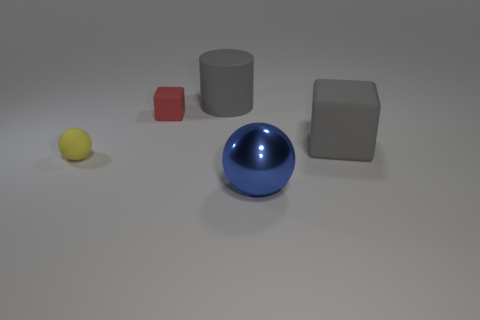Add 3 cyan rubber cylinders. How many objects exist? 8 Subtract all cylinders. How many objects are left? 4 Add 5 tiny balls. How many tiny balls exist? 6 Subtract 0 blue cubes. How many objects are left? 5 Subtract all gray matte cubes. Subtract all gray things. How many objects are left? 2 Add 3 cylinders. How many cylinders are left? 4 